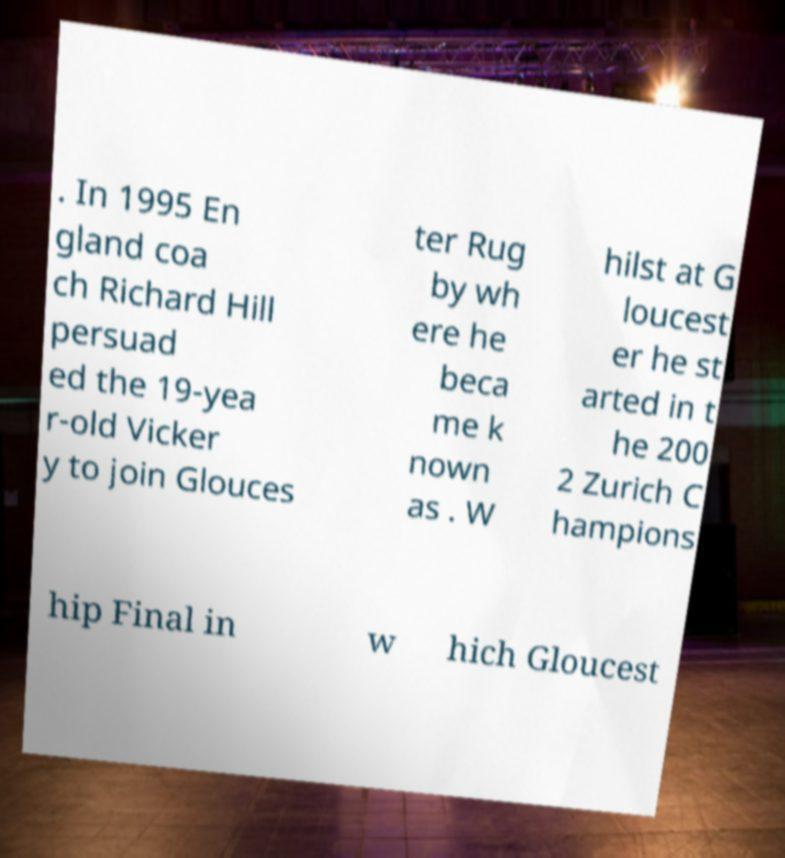Can you read and provide the text displayed in the image?This photo seems to have some interesting text. Can you extract and type it out for me? . In 1995 En gland coa ch Richard Hill persuad ed the 19-yea r-old Vicker y to join Glouces ter Rug by wh ere he beca me k nown as . W hilst at G loucest er he st arted in t he 200 2 Zurich C hampions hip Final in w hich Gloucest 